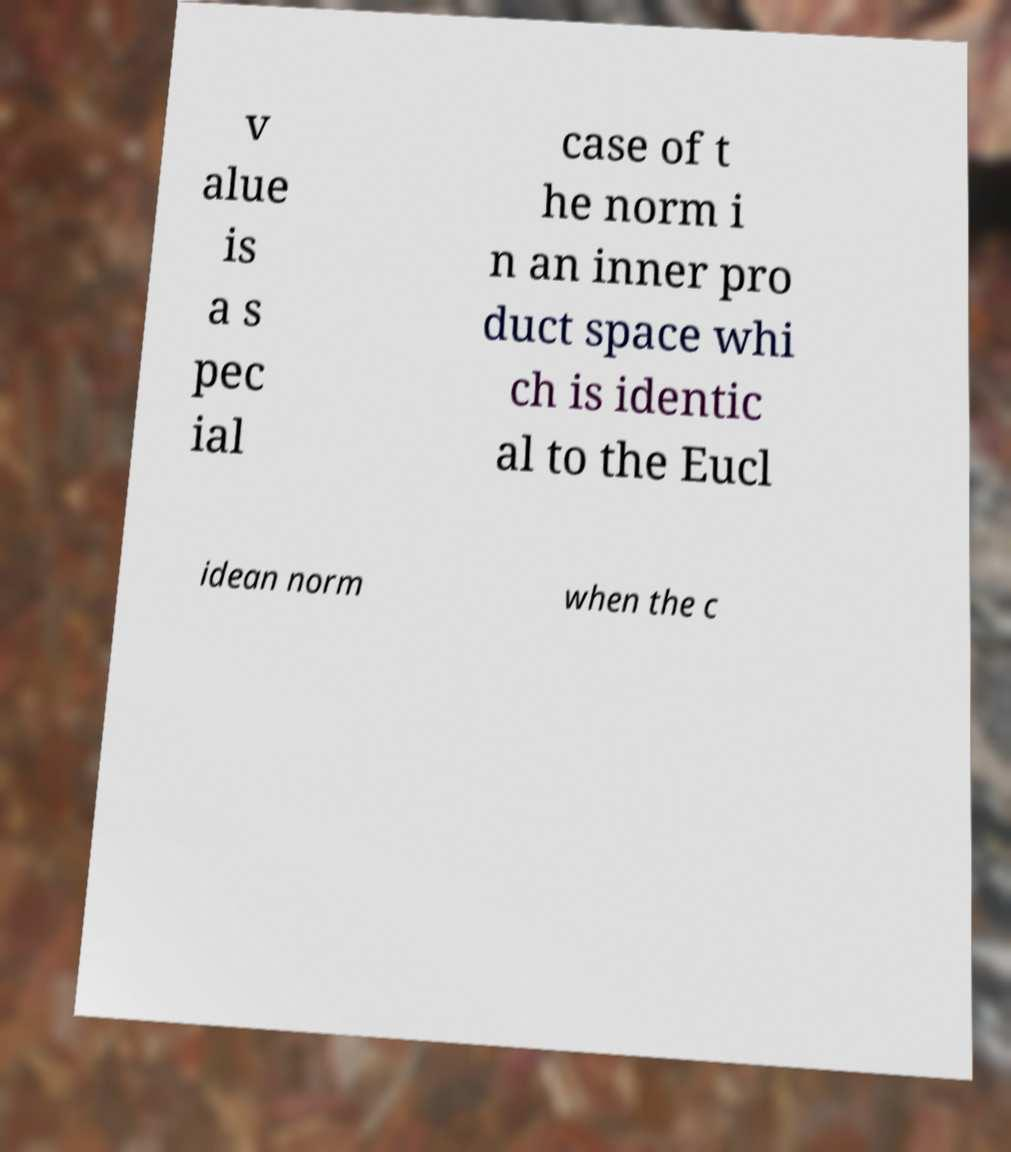For documentation purposes, I need the text within this image transcribed. Could you provide that? v alue is a s pec ial case of t he norm i n an inner pro duct space whi ch is identic al to the Eucl idean norm when the c 